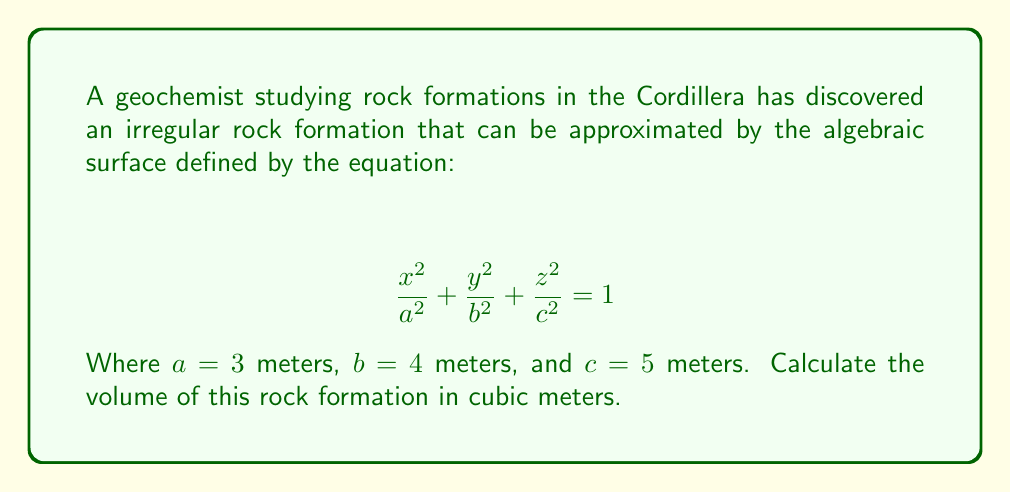Could you help me with this problem? To calculate the volume of this irregular rock formation, we need to follow these steps:

1) Recognize the equation as that of an ellipsoid. The general formula for the volume of an ellipsoid is:

   $$ V = \frac{4}{3}\pi abc $$

2) Substitute the given values:
   $a = 3$ m
   $b = 4$ m
   $c = 5$ m

3) Calculate the volume:

   $$ V = \frac{4}{3}\pi (3)(4)(5) $$

4) Simplify:

   $$ V = \frac{4}{3}\pi (60) = 80\pi $$

5) Calculate the final value (rounded to two decimal places):

   $$ V \approx 251.33 \text{ m}^3 $$

This volume represents the approximate size of the irregular rock formation in the Cordillera, which can be useful for further geochemical analysis and comparison with other formations in the region.
Answer: $251.33 \text{ m}^3$ 